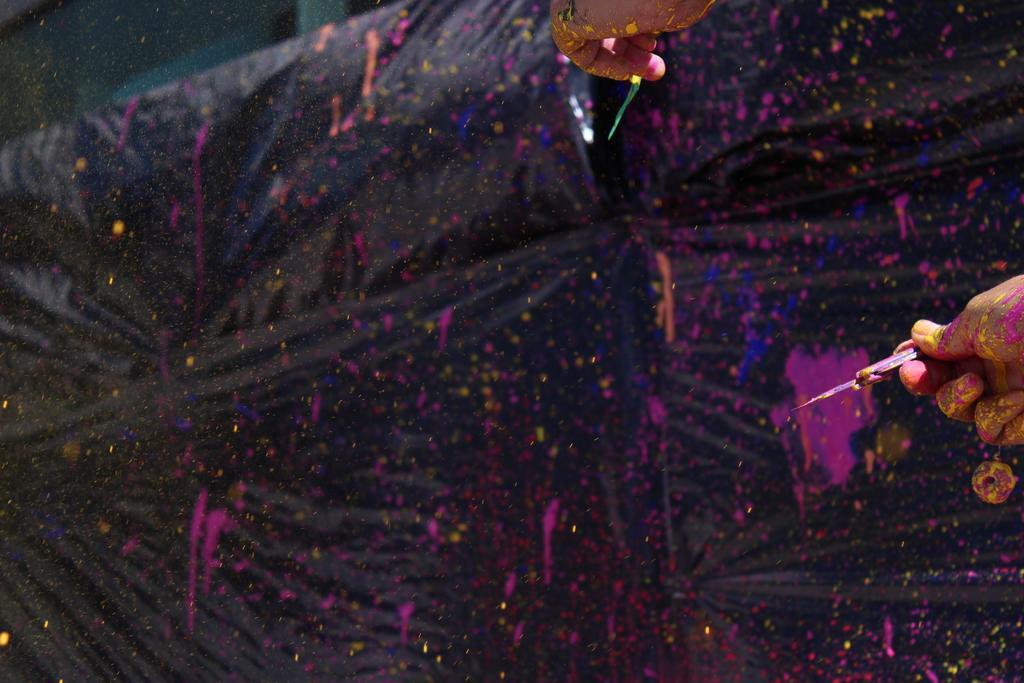How would you summarize this image in a sentence or two? In this picture I can observe a person painting on the black color cloth. I can observe pink and blue colors in this picture. 